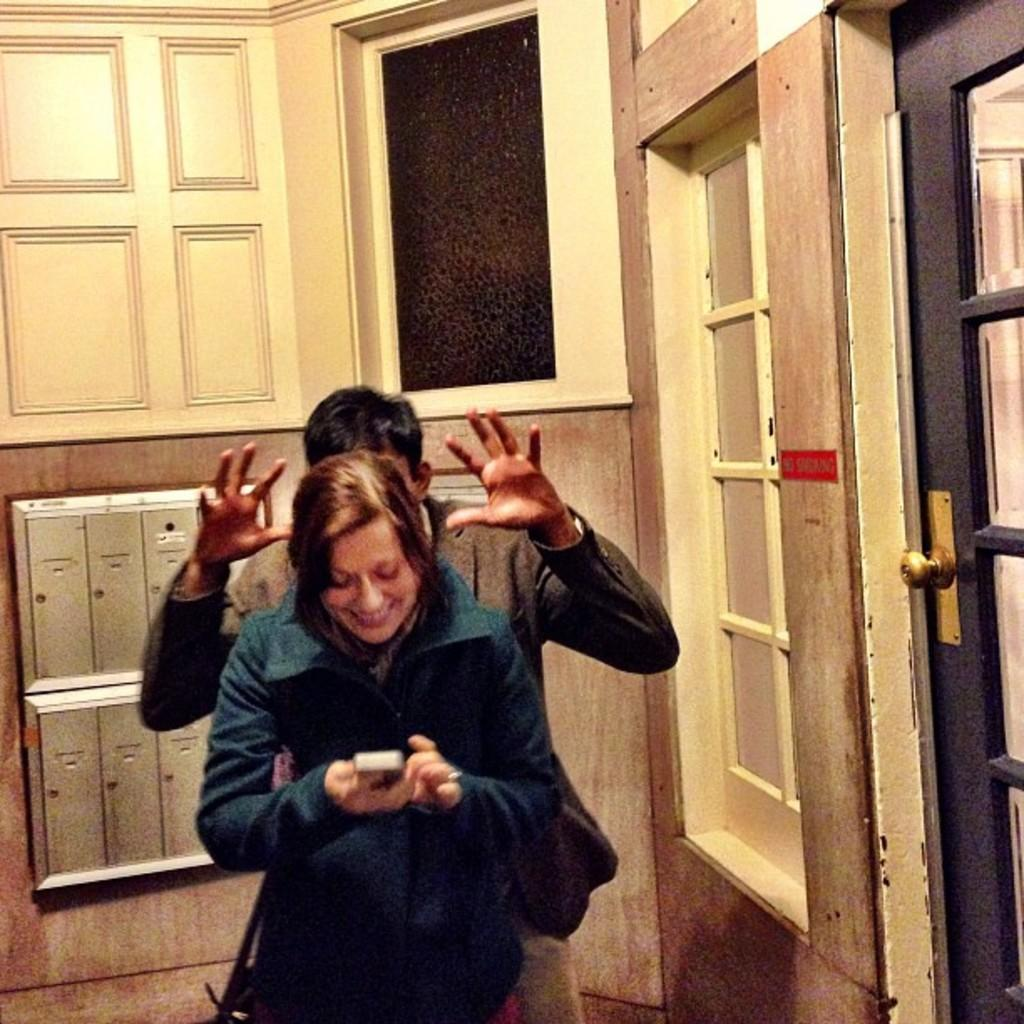How many people are in the image? There are two people in the image. What are the people wearing? The people are wearing dresses. What can be seen to the right in the image? There is a door and a window to the right in the image. What is visible in the background of the image? There are objects visible in the background of the image. What type of tools does the carpenter have in the image? There is no carpenter present in the image, so no tools can be observed. What is the servant doing in the image? There is no servant present in the image, so their actions cannot be described. 